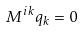Convert formula to latex. <formula><loc_0><loc_0><loc_500><loc_500>M ^ { i k } q _ { k } = 0 \,</formula> 